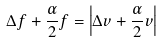Convert formula to latex. <formula><loc_0><loc_0><loc_500><loc_500>\Delta f + \frac { \alpha } { 2 } f = \left | \Delta v + \frac { \alpha } { 2 } v \right |</formula> 